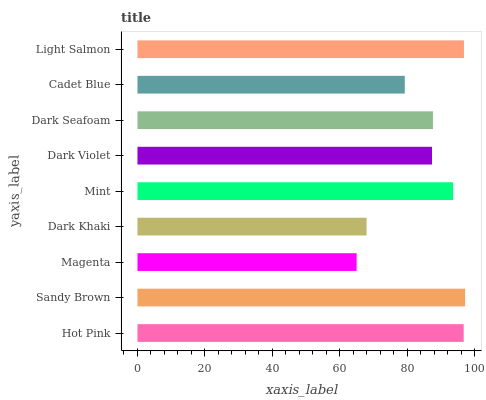Is Magenta the minimum?
Answer yes or no. Yes. Is Sandy Brown the maximum?
Answer yes or no. Yes. Is Sandy Brown the minimum?
Answer yes or no. No. Is Magenta the maximum?
Answer yes or no. No. Is Sandy Brown greater than Magenta?
Answer yes or no. Yes. Is Magenta less than Sandy Brown?
Answer yes or no. Yes. Is Magenta greater than Sandy Brown?
Answer yes or no. No. Is Sandy Brown less than Magenta?
Answer yes or no. No. Is Dark Seafoam the high median?
Answer yes or no. Yes. Is Dark Seafoam the low median?
Answer yes or no. Yes. Is Dark Violet the high median?
Answer yes or no. No. Is Light Salmon the low median?
Answer yes or no. No. 